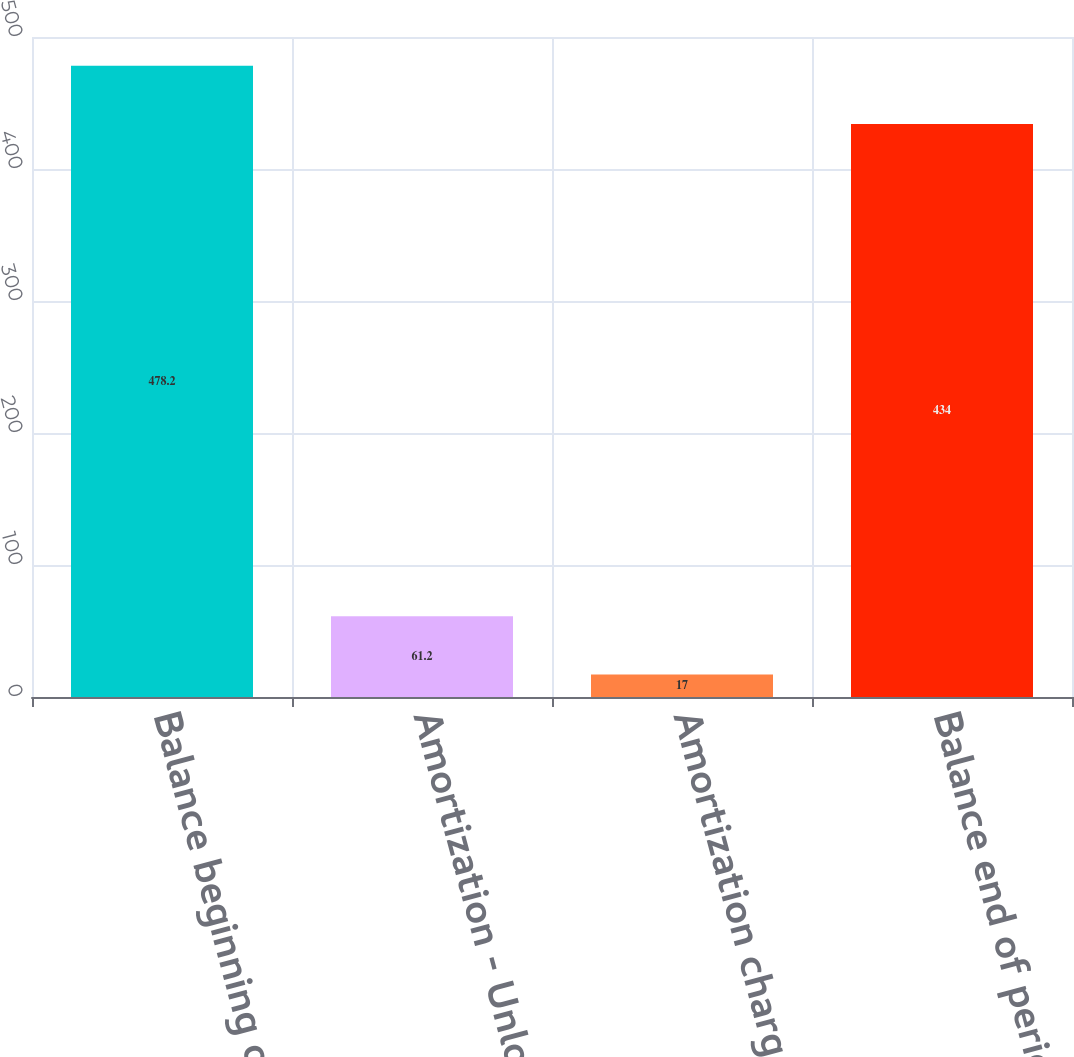Convert chart to OTSL. <chart><loc_0><loc_0><loc_500><loc_500><bar_chart><fcel>Balance beginning of period<fcel>Amortization - Unlock charge 1<fcel>Amortization charged to income<fcel>Balance end of period<nl><fcel>478.2<fcel>61.2<fcel>17<fcel>434<nl></chart> 